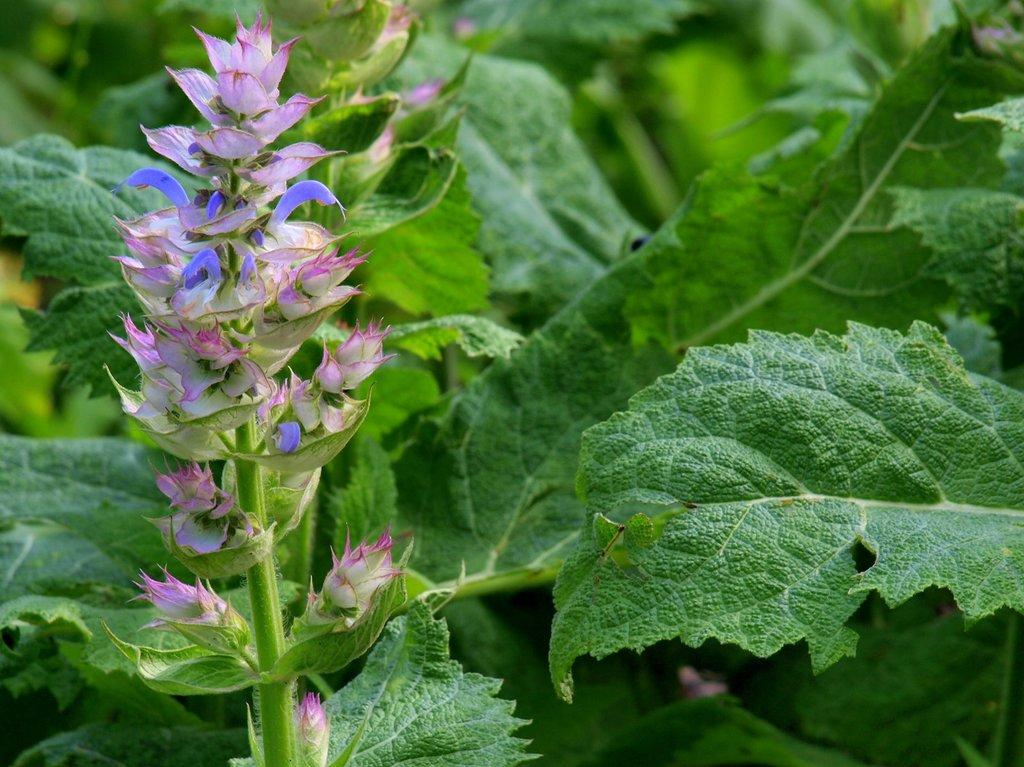What type of plant is visible in the image? There is a plant in the image, and it has flowers and leaves. Are there any other plants visible in the image? Yes, there are other plants in the background of the image. What features do these background plants have? These background plants also have leaves. How many passengers are sitting on the duck in the image? There is no duck or passengers present in the image. 